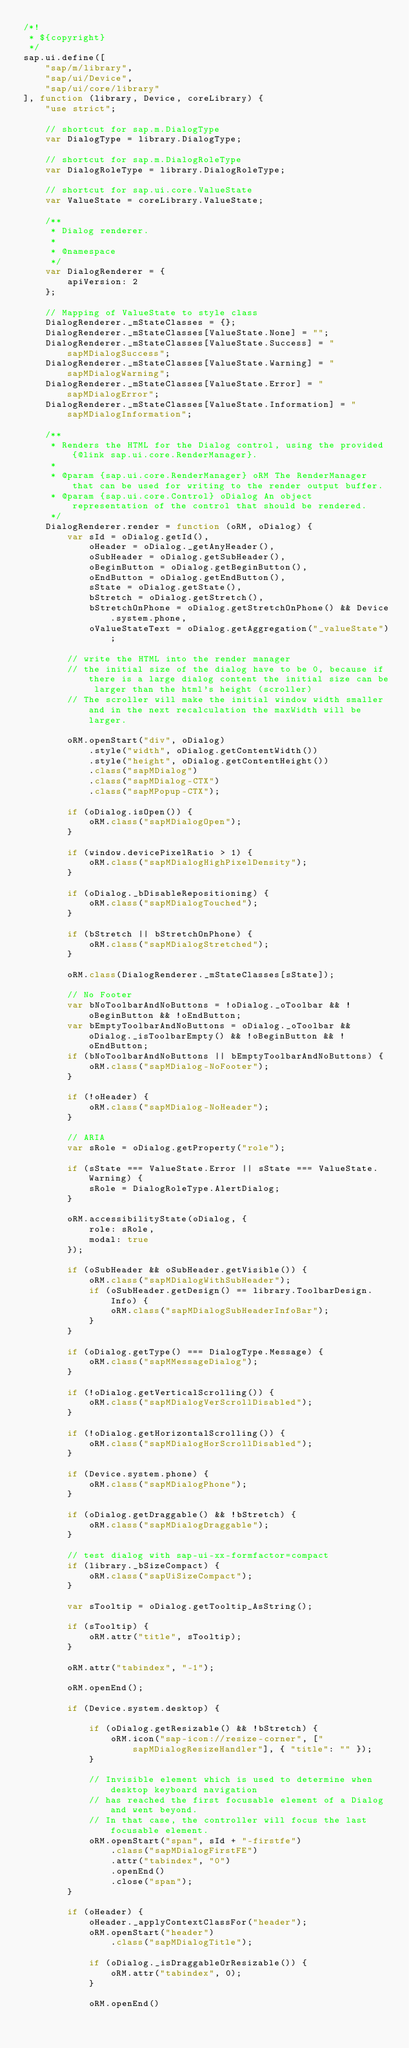<code> <loc_0><loc_0><loc_500><loc_500><_JavaScript_>/*!
 * ${copyright}
 */
sap.ui.define([
	"sap/m/library",
	"sap/ui/Device",
	"sap/ui/core/library"
], function (library, Device, coreLibrary) {
	"use strict";

	// shortcut for sap.m.DialogType
	var DialogType = library.DialogType;

	// shortcut for sap.m.DialogRoleType
	var DialogRoleType = library.DialogRoleType;

	// shortcut for sap.ui.core.ValueState
	var ValueState = coreLibrary.ValueState;

	/**
	 * Dialog renderer.
	 *
	 * @namespace
	 */
	var DialogRenderer = {
		apiVersion: 2
	};

	// Mapping of ValueState to style class
	DialogRenderer._mStateClasses = {};
	DialogRenderer._mStateClasses[ValueState.None] = "";
	DialogRenderer._mStateClasses[ValueState.Success] = "sapMDialogSuccess";
	DialogRenderer._mStateClasses[ValueState.Warning] = "sapMDialogWarning";
	DialogRenderer._mStateClasses[ValueState.Error] = "sapMDialogError";
	DialogRenderer._mStateClasses[ValueState.Information] = "sapMDialogInformation";

	/**
	 * Renders the HTML for the Dialog control, using the provided {@link sap.ui.core.RenderManager}.
	 *
	 * @param {sap.ui.core.RenderManager} oRM The RenderManager that can be used for writing to the render output buffer.
	 * @param {sap.ui.core.Control} oDialog An object representation of the control that should be rendered.
	 */
	DialogRenderer.render = function (oRM, oDialog) {
		var sId = oDialog.getId(),
			oHeader = oDialog._getAnyHeader(),
			oSubHeader = oDialog.getSubHeader(),
			oBeginButton = oDialog.getBeginButton(),
			oEndButton = oDialog.getEndButton(),
			sState = oDialog.getState(),
			bStretch = oDialog.getStretch(),
			bStretchOnPhone = oDialog.getStretchOnPhone() && Device.system.phone,
			oValueStateText = oDialog.getAggregation("_valueState");

		// write the HTML into the render manager
		// the initial size of the dialog have to be 0, because if there is a large dialog content the initial size can be larger than the html's height (scroller)
		// The scroller will make the initial window width smaller and in the next recalculation the maxWidth will be larger.

		oRM.openStart("div", oDialog)
			.style("width", oDialog.getContentWidth())
			.style("height", oDialog.getContentHeight())
			.class("sapMDialog")
			.class("sapMDialog-CTX")
			.class("sapMPopup-CTX");

		if (oDialog.isOpen()) {
			oRM.class("sapMDialogOpen");
		}

		if (window.devicePixelRatio > 1) {
			oRM.class("sapMDialogHighPixelDensity");
		}

		if (oDialog._bDisableRepositioning) {
			oRM.class("sapMDialogTouched");
		}

		if (bStretch || bStretchOnPhone) {
			oRM.class("sapMDialogStretched");
		}

		oRM.class(DialogRenderer._mStateClasses[sState]);

		// No Footer
		var bNoToolbarAndNoButtons = !oDialog._oToolbar && !oBeginButton && !oEndButton;
		var bEmptyToolbarAndNoButtons = oDialog._oToolbar && oDialog._isToolbarEmpty() && !oBeginButton && !oEndButton;
		if (bNoToolbarAndNoButtons || bEmptyToolbarAndNoButtons) {
			oRM.class("sapMDialog-NoFooter");
		}

		if (!oHeader) {
			oRM.class("sapMDialog-NoHeader");
		}

		// ARIA
		var sRole = oDialog.getProperty("role");

		if (sState === ValueState.Error || sState === ValueState.Warning) {
			sRole = DialogRoleType.AlertDialog;
		}

		oRM.accessibilityState(oDialog, {
			role: sRole,
			modal: true
		});

		if (oSubHeader && oSubHeader.getVisible()) {
			oRM.class("sapMDialogWithSubHeader");
			if (oSubHeader.getDesign() == library.ToolbarDesign.Info) {
				oRM.class("sapMDialogSubHeaderInfoBar");
			}
		}

		if (oDialog.getType() === DialogType.Message) {
			oRM.class("sapMMessageDialog");
		}

		if (!oDialog.getVerticalScrolling()) {
			oRM.class("sapMDialogVerScrollDisabled");
		}

		if (!oDialog.getHorizontalScrolling()) {
			oRM.class("sapMDialogHorScrollDisabled");
		}

		if (Device.system.phone) {
			oRM.class("sapMDialogPhone");
		}

		if (oDialog.getDraggable() && !bStretch) {
			oRM.class("sapMDialogDraggable");
		}

		// test dialog with sap-ui-xx-formfactor=compact
		if (library._bSizeCompact) {
			oRM.class("sapUiSizeCompact");
		}

		var sTooltip = oDialog.getTooltip_AsString();

		if (sTooltip) {
			oRM.attr("title", sTooltip);
		}

		oRM.attr("tabindex", "-1");

		oRM.openEnd();

		if (Device.system.desktop) {

			if (oDialog.getResizable() && !bStretch) {
				oRM.icon("sap-icon://resize-corner", ["sapMDialogResizeHandler"], { "title": "" });
			}

			// Invisible element which is used to determine when desktop keyboard navigation
			// has reached the first focusable element of a Dialog and went beyond.
			// In that case, the controller will focus the last focusable element.
			oRM.openStart("span", sId + "-firstfe")
				.class("sapMDialogFirstFE")
				.attr("tabindex", "0")
				.openEnd()
				.close("span");
		}

		if (oHeader) {
			oHeader._applyContextClassFor("header");
			oRM.openStart("header")
				.class("sapMDialogTitle");

			if (oDialog._isDraggableOrResizable()) {
				oRM.attr("tabindex", 0);
			}

			oRM.openEnd()</code> 